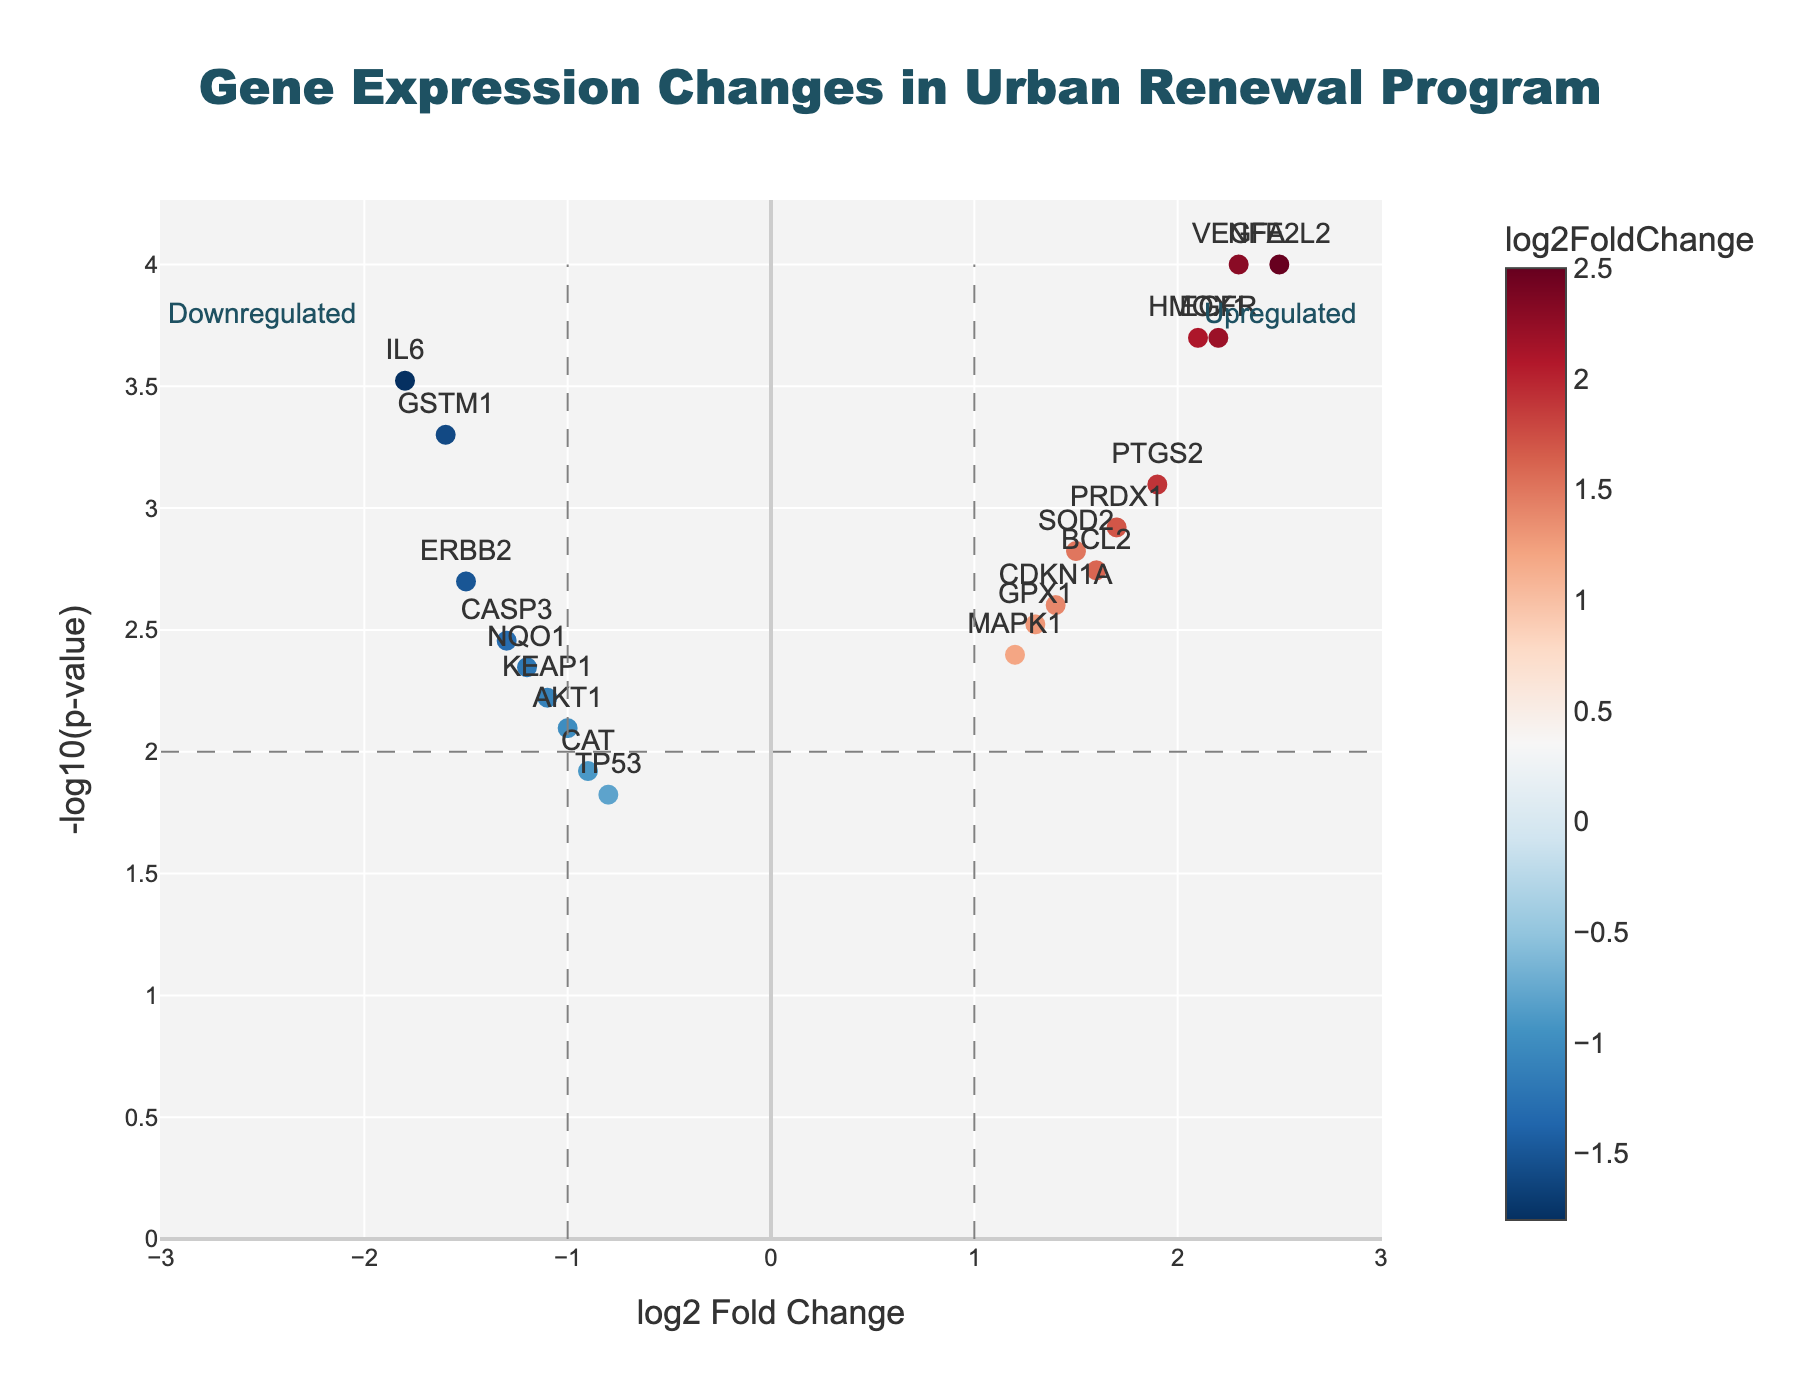What is the title of the figure? The title can be found at the top of the figure, where it says "Gene Expression Changes in Urban Renewal Program".
Answer: Gene Expression Changes in Urban Renewal Program What does the x-axis represent? The x-axis is labeled as "log2 Fold Change," indicating it represents the log2 fold change in gene expression.
Answer: log2 Fold Change Which gene has the highest log2 Fold Change? Look for the data point that is furthest to the right on the x-axis, which corresponds to NFE2L2 with a log2 Fold Change of 2.5.
Answer: NFE2L2 Which genes are upregulated significantly? Upregulated genes lie to the right of the vertical line at log2 Fold Change = 1. Meanwhile, significance is indicated by being above the dashed horizontal line for p-value threshold. Look at which points meet both conditions to identify these genes: VEGFA, EGFR, HMOX1, PTGS2, BCL2, PRDX1, SOD2, CDKN1A, and GPX1.
Answer: VEGFA, EGFR, HMOX1, PTGS2, BCL2, PRDX1, SOD2, CDKN1A, GPX1 Which genes are positioned exactly on the dashed vertical line at log2 Fold Change = -1? Check the data points that lie on the dashed vertical line at log2 Fold Change = -1. The gene corresponding to this line is KEAP1.
Answer: KEAP1 Which gene has the lowest p-value? The lowest p-value will correspond to the highest point on the y-axis. This gene is NFE2L2 with a p-value of 0.0001, thus having the highest -log10(p-value) value.
Answer: NFE2L2 How many genes have a log2 Fold Change greater than 2? Count the number of data points located to the right of the log2 Fold Change = 2 vertical line. These are NFE2L2, VEGFA, and EGFR.
Answer: 3 Which gene has the highest -log10(p-value) among the downregulated genes? Look at the points on the left side of the vertical line at log2 Fold Change = -1 and identify which one is the highest. IL6 is the highest among the downregulated genes.
Answer: IL6 What is the significance threshold for p-value in this plot? The significance threshold can be found where the dashed horizontal line is drawn; it is at -log10(p-value) = 2, which corresponds to p = 0.01.
Answer: 0.01 How many genes fall into the downregulated and non-significant category? Identify genes with log2 Fold Change < -1 and -log10(p-value) < 2. The genes in this category are NQO1, CASP3, and CAT.
Answer: 3 